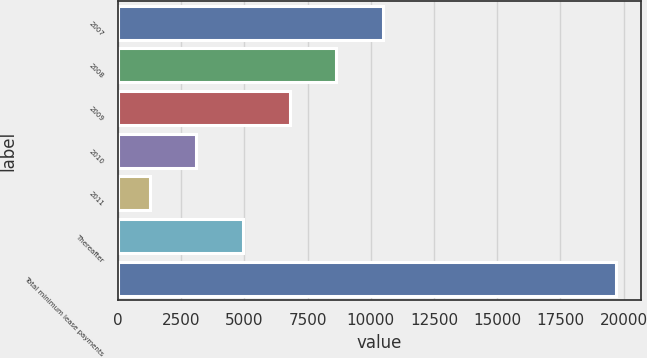Convert chart to OTSL. <chart><loc_0><loc_0><loc_500><loc_500><bar_chart><fcel>2007<fcel>2008<fcel>2009<fcel>2010<fcel>2011<fcel>Thereafter<fcel>Total minimum lease payments<nl><fcel>10482<fcel>8635.6<fcel>6789.2<fcel>3096.4<fcel>1250<fcel>4942.8<fcel>19714<nl></chart> 